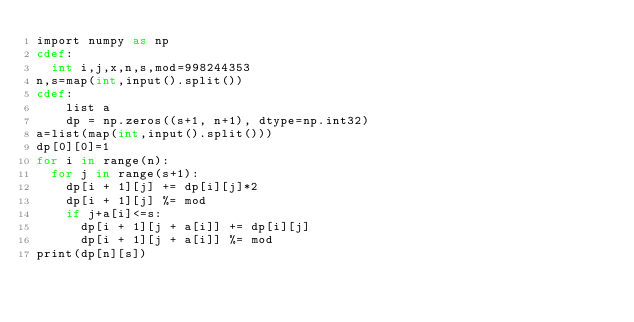<code> <loc_0><loc_0><loc_500><loc_500><_Cython_>import numpy as np
cdef:
  int i,j,x,n,s,mod=998244353
n,s=map(int,input().split())
cdef:
    list a
    dp = np.zeros((s+1, n+1), dtype=np.int32)
a=list(map(int,input().split()))
dp[0][0]=1
for i in range(n):
  for j in range(s+1):
    dp[i + 1][j] += dp[i][j]*2
    dp[i + 1][j] %= mod
    if j+a[i]<=s:
      dp[i + 1][j + a[i]] += dp[i][j]
      dp[i + 1][j + a[i]] %= mod
print(dp[n][s])</code> 